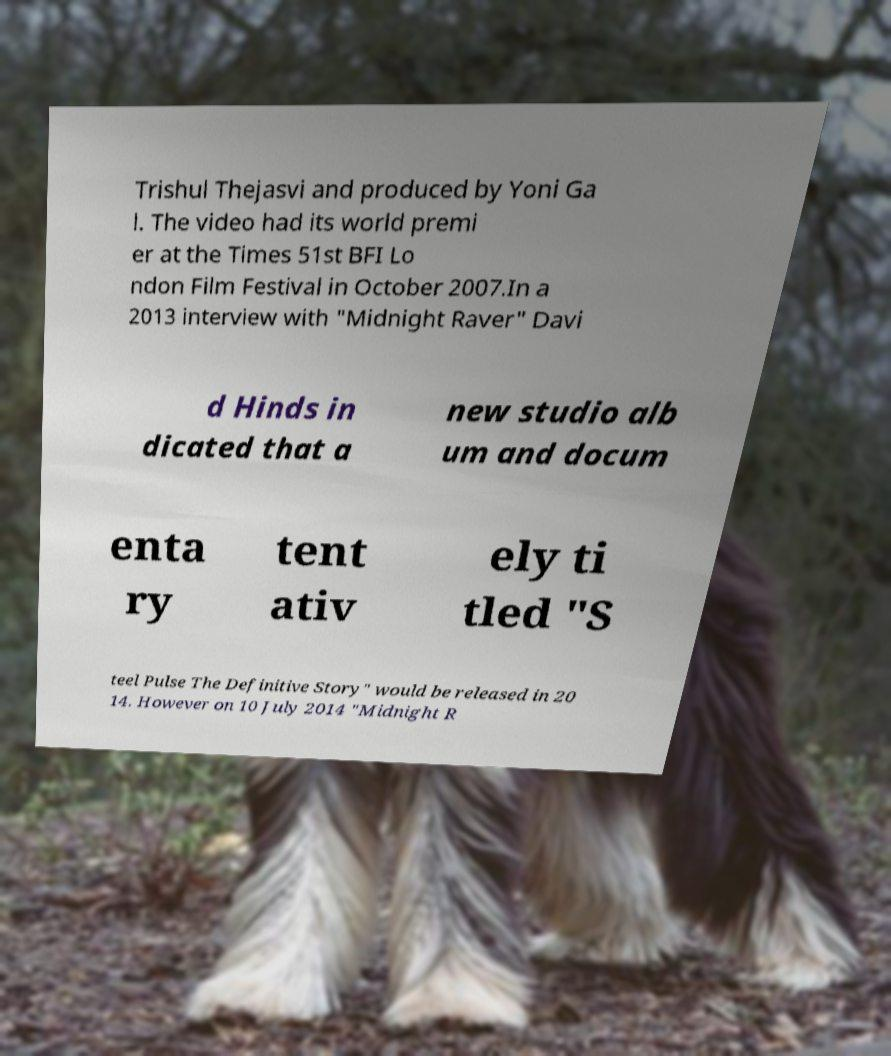For documentation purposes, I need the text within this image transcribed. Could you provide that? Trishul Thejasvi and produced by Yoni Ga l. The video had its world premi er at the Times 51st BFI Lo ndon Film Festival in October 2007.In a 2013 interview with "Midnight Raver" Davi d Hinds in dicated that a new studio alb um and docum enta ry tent ativ ely ti tled "S teel Pulse The Definitive Story" would be released in 20 14. However on 10 July 2014 "Midnight R 